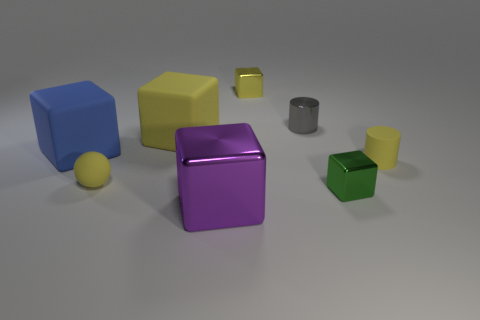Can you describe the texture and color of the object that is furthest on the left? The furthest object on the left appears to be a blue cube with a smooth, matte surface. 